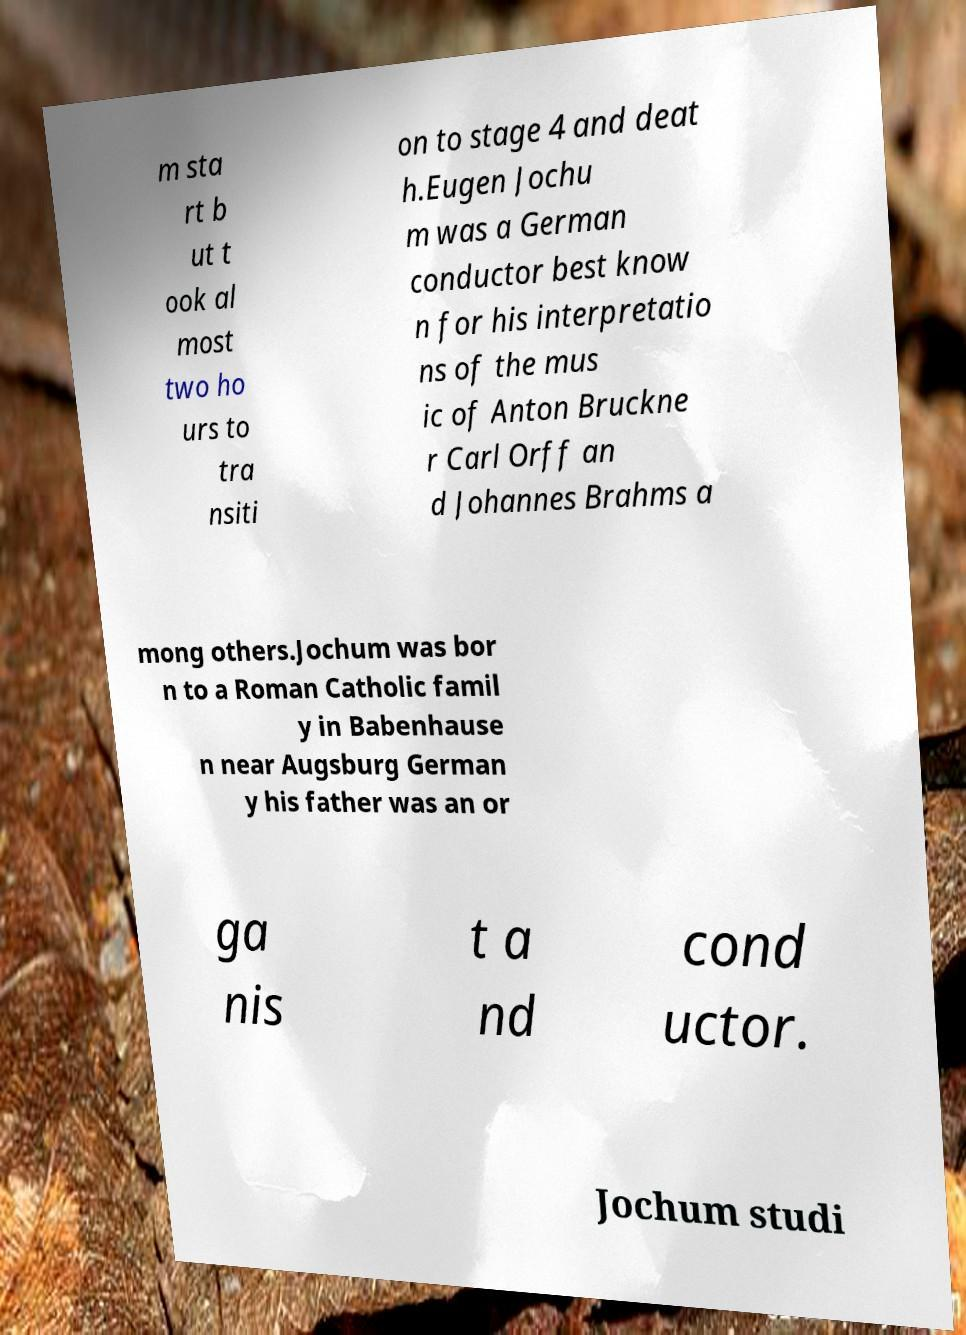There's text embedded in this image that I need extracted. Can you transcribe it verbatim? m sta rt b ut t ook al most two ho urs to tra nsiti on to stage 4 and deat h.Eugen Jochu m was a German conductor best know n for his interpretatio ns of the mus ic of Anton Bruckne r Carl Orff an d Johannes Brahms a mong others.Jochum was bor n to a Roman Catholic famil y in Babenhause n near Augsburg German y his father was an or ga nis t a nd cond uctor. Jochum studi 